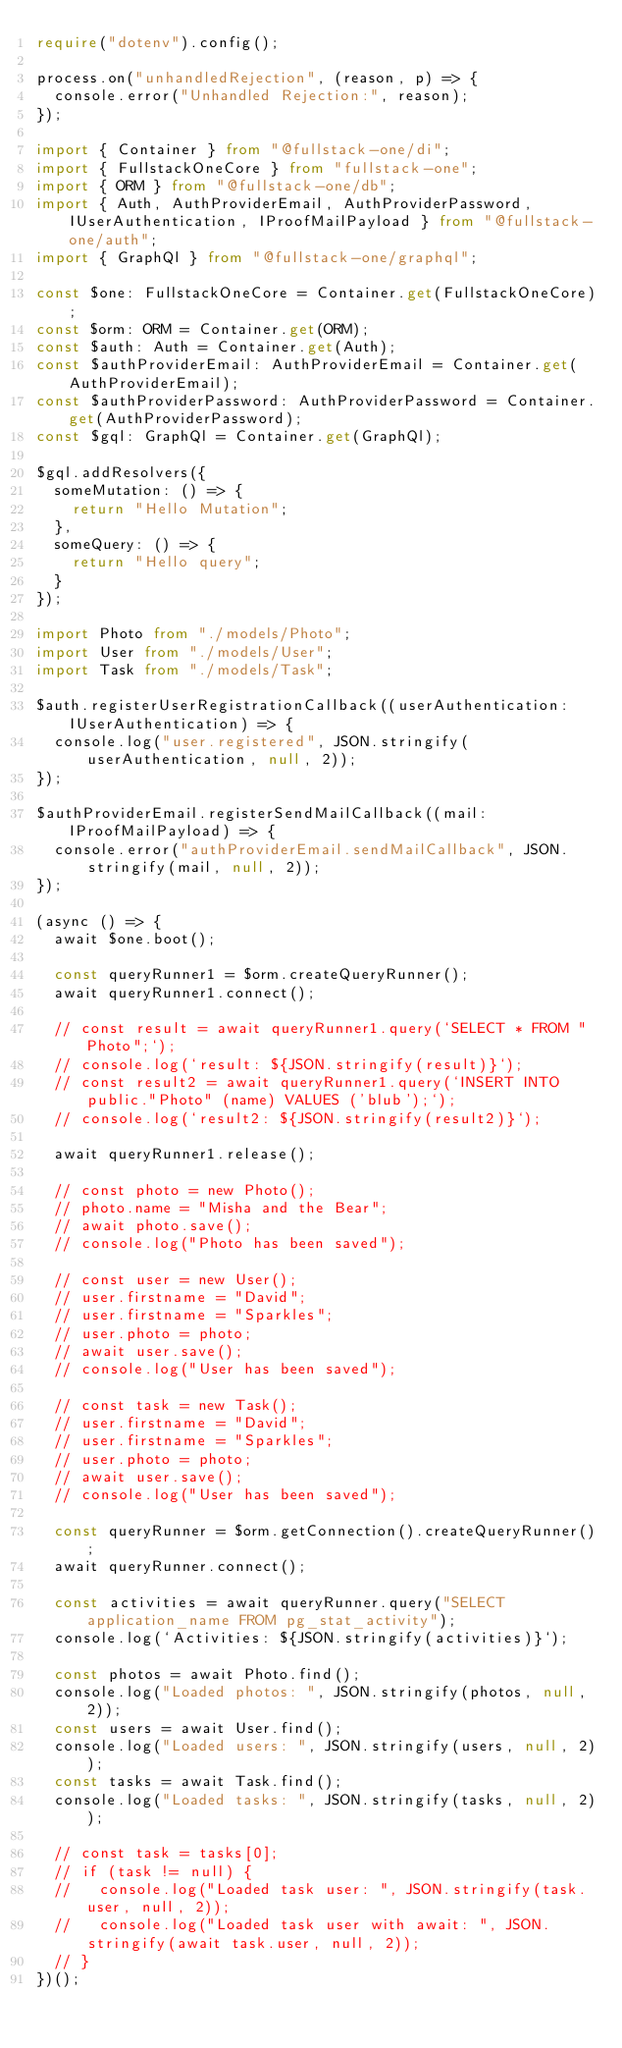<code> <loc_0><loc_0><loc_500><loc_500><_TypeScript_>require("dotenv").config();

process.on("unhandledRejection", (reason, p) => {
  console.error("Unhandled Rejection:", reason);
});

import { Container } from "@fullstack-one/di";
import { FullstackOneCore } from "fullstack-one";
import { ORM } from "@fullstack-one/db";
import { Auth, AuthProviderEmail, AuthProviderPassword, IUserAuthentication, IProofMailPayload } from "@fullstack-one/auth";
import { GraphQl } from "@fullstack-one/graphql";

const $one: FullstackOneCore = Container.get(FullstackOneCore);
const $orm: ORM = Container.get(ORM);
const $auth: Auth = Container.get(Auth);
const $authProviderEmail: AuthProviderEmail = Container.get(AuthProviderEmail);
const $authProviderPassword: AuthProviderPassword = Container.get(AuthProviderPassword);
const $gql: GraphQl = Container.get(GraphQl);

$gql.addResolvers({
  someMutation: () => {
    return "Hello Mutation";
  },
  someQuery: () => {
    return "Hello query";
  }
});

import Photo from "./models/Photo";
import User from "./models/User";
import Task from "./models/Task";

$auth.registerUserRegistrationCallback((userAuthentication: IUserAuthentication) => {
  console.log("user.registered", JSON.stringify(userAuthentication, null, 2));
});

$authProviderEmail.registerSendMailCallback((mail: IProofMailPayload) => {
  console.error("authProviderEmail.sendMailCallback", JSON.stringify(mail, null, 2));
});

(async () => {
  await $one.boot();

  const queryRunner1 = $orm.createQueryRunner();
  await queryRunner1.connect();

  // const result = await queryRunner1.query(`SELECT * FROM "Photo";`);
  // console.log(`result: ${JSON.stringify(result)}`);
  // const result2 = await queryRunner1.query(`INSERT INTO public."Photo" (name) VALUES ('blub');`);
  // console.log(`result2: ${JSON.stringify(result2)}`);

  await queryRunner1.release();

  // const photo = new Photo();
  // photo.name = "Misha and the Bear";
  // await photo.save();
  // console.log("Photo has been saved");

  // const user = new User();
  // user.firstname = "David";
  // user.firstname = "Sparkles";
  // user.photo = photo;
  // await user.save();
  // console.log("User has been saved");

  // const task = new Task();
  // user.firstname = "David";
  // user.firstname = "Sparkles";
  // user.photo = photo;
  // await user.save();
  // console.log("User has been saved");

  const queryRunner = $orm.getConnection().createQueryRunner();
  await queryRunner.connect();

  const activities = await queryRunner.query("SELECT application_name FROM pg_stat_activity");
  console.log(`Activities: ${JSON.stringify(activities)}`);

  const photos = await Photo.find();
  console.log("Loaded photos: ", JSON.stringify(photos, null, 2));
  const users = await User.find();
  console.log("Loaded users: ", JSON.stringify(users, null, 2));
  const tasks = await Task.find();
  console.log("Loaded tasks: ", JSON.stringify(tasks, null, 2));

  // const task = tasks[0];
  // if (task != null) {
  //   console.log("Loaded task user: ", JSON.stringify(task.user, null, 2));
  //   console.log("Loaded task user with await: ", JSON.stringify(await task.user, null, 2));
  // }
})();
</code> 